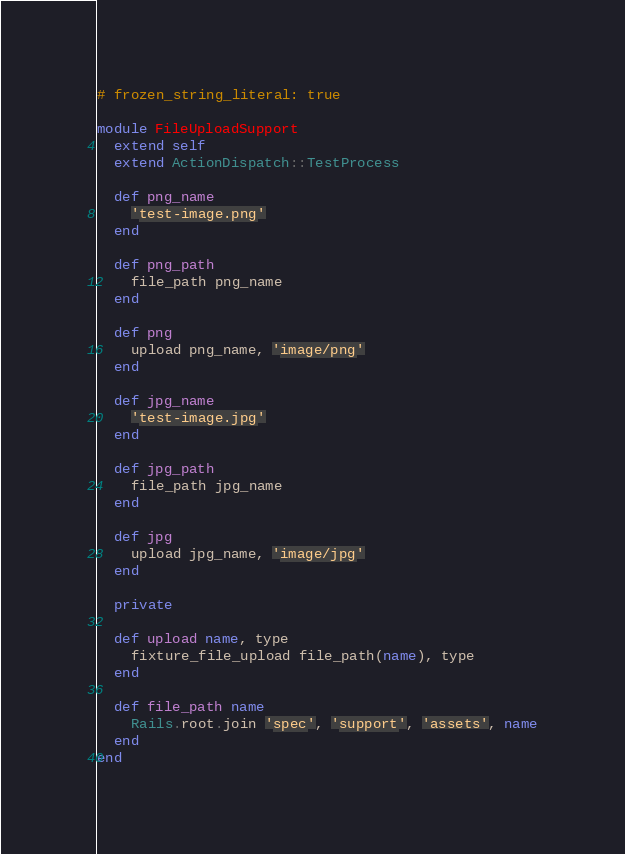Convert code to text. <code><loc_0><loc_0><loc_500><loc_500><_Ruby_># frozen_string_literal: true

module FileUploadSupport
  extend self
  extend ActionDispatch::TestProcess

  def png_name
    'test-image.png'
  end

  def png_path
    file_path png_name
  end

  def png
    upload png_name, 'image/png'
  end

  def jpg_name
    'test-image.jpg'
  end

  def jpg_path
    file_path jpg_name
  end

  def jpg
    upload jpg_name, 'image/jpg'
  end

  private

  def upload name, type
    fixture_file_upload file_path(name), type
  end

  def file_path name
    Rails.root.join 'spec', 'support', 'assets', name
  end
end
</code> 